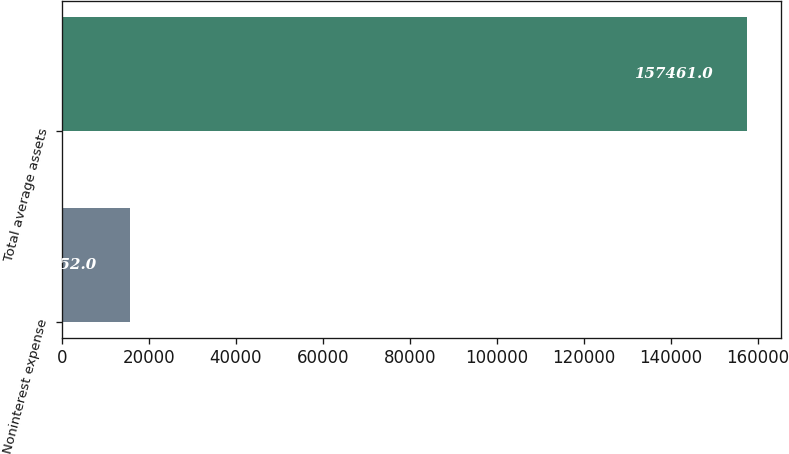Convert chart. <chart><loc_0><loc_0><loc_500><loc_500><bar_chart><fcel>Noninterest expense<fcel>Total average assets<nl><fcel>15652<fcel>157461<nl></chart> 